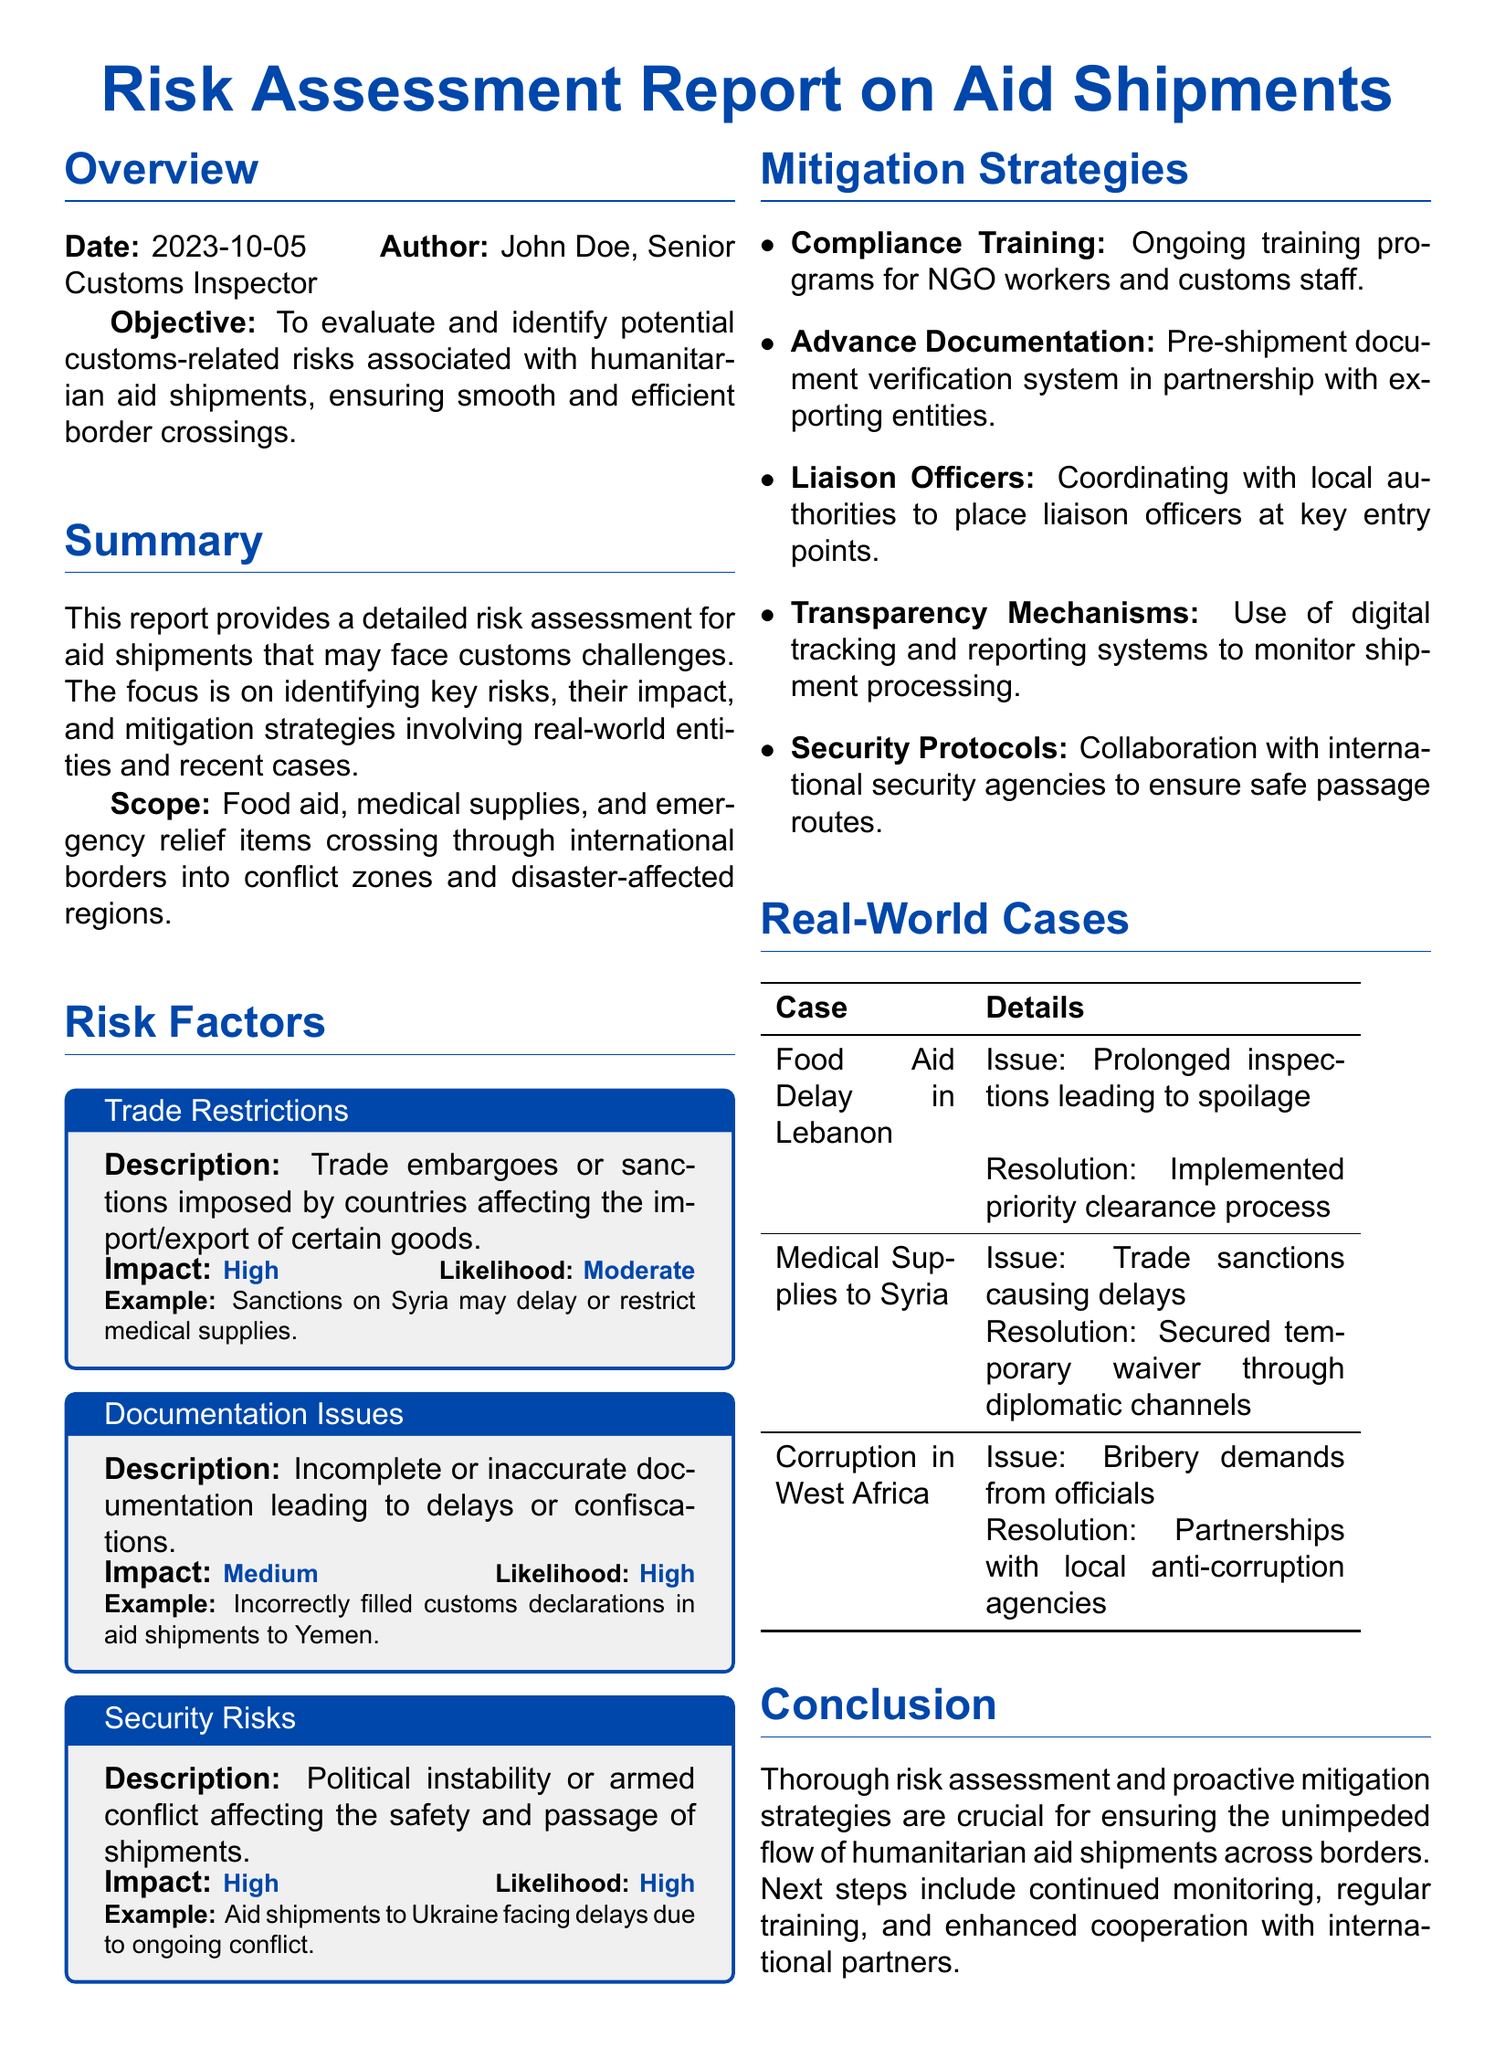What is the date of the report? The date of the report is stated in the Overview section.
Answer: 2023-10-05 Who is the author of the report? The author of the report is listed in the Overview section.
Answer: John Doe, Senior Customs Inspector What is the impact level of trade restrictions? The impact level for trade restrictions is mentioned in the Risk Factors section.
Answer: High What kind of aid is the report focusing on? The scope of the report details the types of aid shipments being evaluated.
Answer: Food aid, medical supplies, and emergency relief items What issue caused the food aid delay in Lebanon? The specific issue leading to the delay is outlined in the Real-World Cases section.
Answer: Prolonged inspections leading to spoilage What mitigation strategy involves training programs? The mitigation strategy that includes training programs is identified in the Mitigation Strategies section.
Answer: Compliance Training What is the likelihood level of security risks? The likelihood level for security risks is provided in the Risk Factors section.
Answer: High Which country faced delays due to trade sanctions? The country facing delays due to trade sanctions is stated in the Real-World Cases section.
Answer: Syria What resolution was implemented for medical supplies to Syria? The resolution for medical supplies to Syria is detailed in the Real-World Cases section.
Answer: Secured temporary waiver through diplomatic channels 